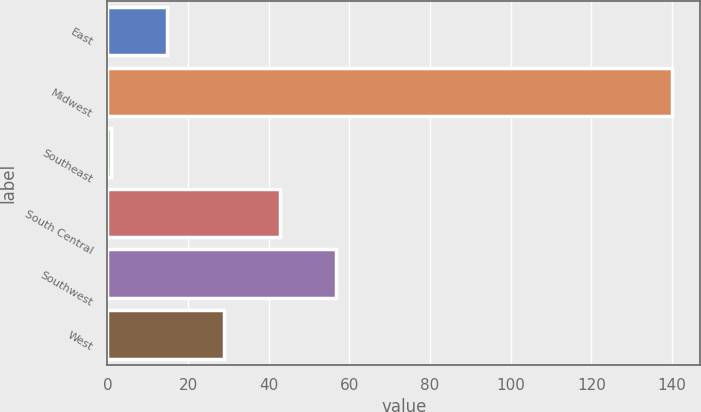Convert chart to OTSL. <chart><loc_0><loc_0><loc_500><loc_500><bar_chart><fcel>East<fcel>Midwest<fcel>Southeast<fcel>South Central<fcel>Southwest<fcel>West<nl><fcel>14.9<fcel>140<fcel>1<fcel>42.7<fcel>56.6<fcel>28.8<nl></chart> 